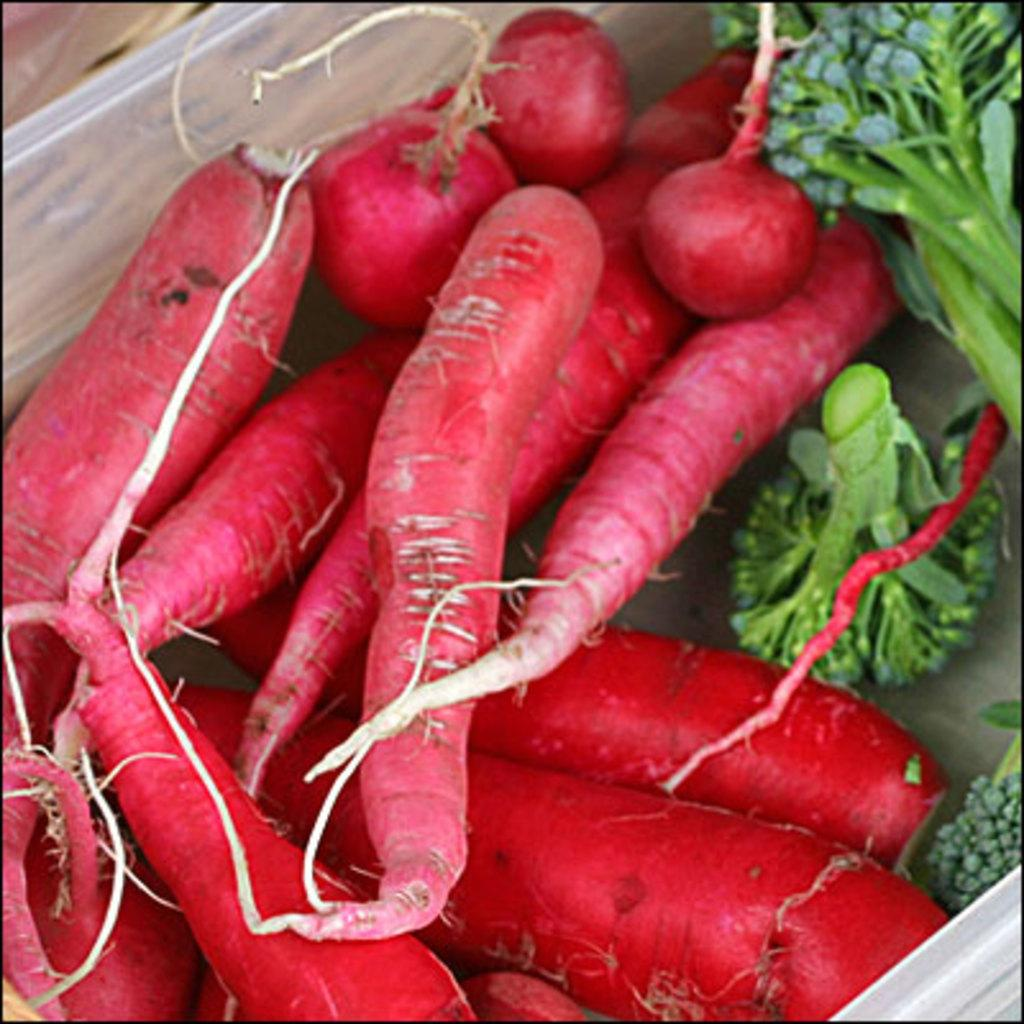What type of vegetable can be seen in the image? There is broccoli in the image. Are there any other vegetables visible in the image? Yes, there are radishes in the image. What type of chess piece is visible in the image? There is no chess piece present in the image; it only features broccoli and radishes. What news headline can be seen in the image? There is no news headline present in the image; it only features broccoli and radishes. 